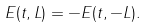Convert formula to latex. <formula><loc_0><loc_0><loc_500><loc_500>E ( t , L ) = - E ( t , - L ) .</formula> 